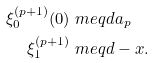Convert formula to latex. <formula><loc_0><loc_0><loc_500><loc_500>\xi _ { 0 } ^ { ( p + 1 ) } ( 0 ) & \ m e q d a _ { p } \\ \xi _ { 1 } ^ { ( p + 1 ) } & \ m e q d - x .</formula> 